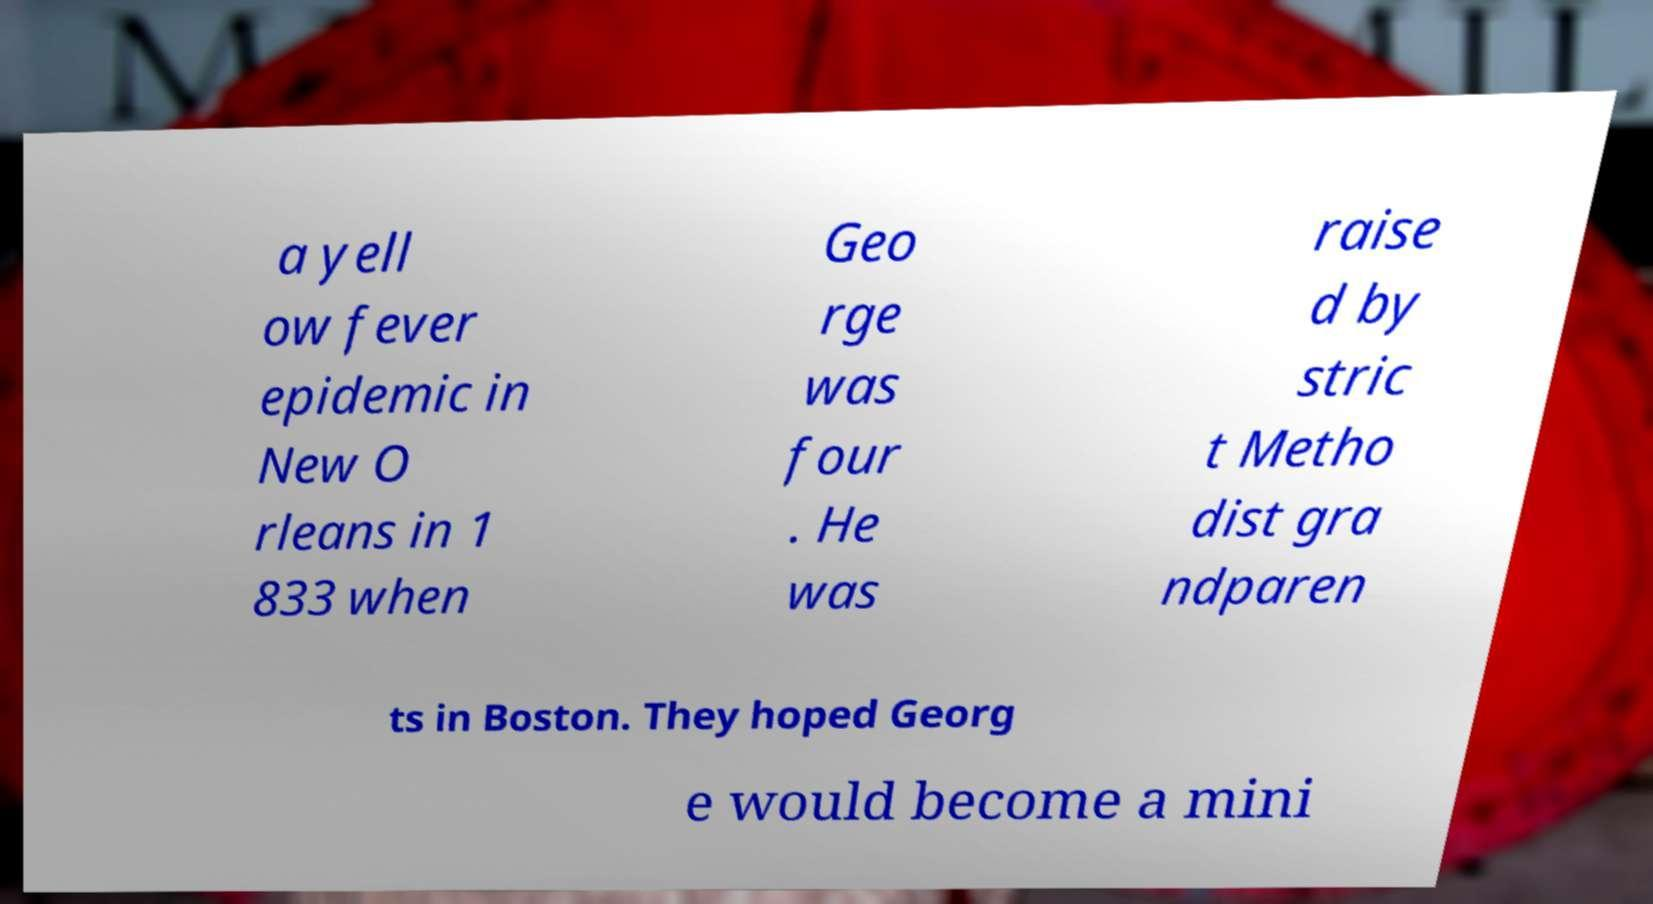Can you read and provide the text displayed in the image?This photo seems to have some interesting text. Can you extract and type it out for me? a yell ow fever epidemic in New O rleans in 1 833 when Geo rge was four . He was raise d by stric t Metho dist gra ndparen ts in Boston. They hoped Georg e would become a mini 